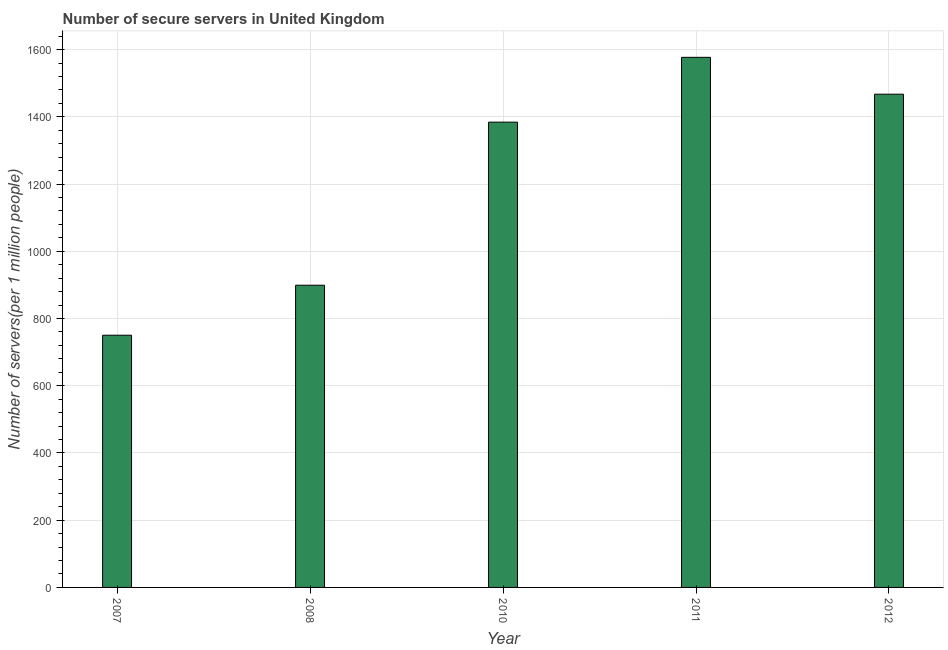Does the graph contain grids?
Provide a short and direct response. Yes. What is the title of the graph?
Offer a very short reply. Number of secure servers in United Kingdom. What is the label or title of the X-axis?
Provide a succinct answer. Year. What is the label or title of the Y-axis?
Your answer should be very brief. Number of servers(per 1 million people). What is the number of secure internet servers in 2012?
Your answer should be compact. 1467.31. Across all years, what is the maximum number of secure internet servers?
Your answer should be very brief. 1576.98. Across all years, what is the minimum number of secure internet servers?
Your answer should be compact. 750.31. In which year was the number of secure internet servers maximum?
Keep it short and to the point. 2011. In which year was the number of secure internet servers minimum?
Provide a succinct answer. 2007. What is the sum of the number of secure internet servers?
Offer a very short reply. 6077.74. What is the difference between the number of secure internet servers in 2007 and 2012?
Ensure brevity in your answer.  -717. What is the average number of secure internet servers per year?
Your answer should be compact. 1215.55. What is the median number of secure internet servers?
Keep it short and to the point. 1384.15. What is the ratio of the number of secure internet servers in 2008 to that in 2010?
Offer a terse response. 0.65. What is the difference between the highest and the second highest number of secure internet servers?
Provide a succinct answer. 109.67. Is the sum of the number of secure internet servers in 2007 and 2012 greater than the maximum number of secure internet servers across all years?
Ensure brevity in your answer.  Yes. What is the difference between the highest and the lowest number of secure internet servers?
Offer a very short reply. 826.67. What is the difference between two consecutive major ticks on the Y-axis?
Keep it short and to the point. 200. Are the values on the major ticks of Y-axis written in scientific E-notation?
Give a very brief answer. No. What is the Number of servers(per 1 million people) in 2007?
Your response must be concise. 750.31. What is the Number of servers(per 1 million people) in 2008?
Ensure brevity in your answer.  898.99. What is the Number of servers(per 1 million people) of 2010?
Your answer should be very brief. 1384.15. What is the Number of servers(per 1 million people) of 2011?
Keep it short and to the point. 1576.98. What is the Number of servers(per 1 million people) in 2012?
Ensure brevity in your answer.  1467.31. What is the difference between the Number of servers(per 1 million people) in 2007 and 2008?
Your answer should be compact. -148.68. What is the difference between the Number of servers(per 1 million people) in 2007 and 2010?
Provide a short and direct response. -633.84. What is the difference between the Number of servers(per 1 million people) in 2007 and 2011?
Offer a terse response. -826.67. What is the difference between the Number of servers(per 1 million people) in 2007 and 2012?
Provide a short and direct response. -717. What is the difference between the Number of servers(per 1 million people) in 2008 and 2010?
Ensure brevity in your answer.  -485.16. What is the difference between the Number of servers(per 1 million people) in 2008 and 2011?
Provide a short and direct response. -677.99. What is the difference between the Number of servers(per 1 million people) in 2008 and 2012?
Offer a very short reply. -568.32. What is the difference between the Number of servers(per 1 million people) in 2010 and 2011?
Your response must be concise. -192.83. What is the difference between the Number of servers(per 1 million people) in 2010 and 2012?
Make the answer very short. -83.16. What is the difference between the Number of servers(per 1 million people) in 2011 and 2012?
Ensure brevity in your answer.  109.67. What is the ratio of the Number of servers(per 1 million people) in 2007 to that in 2008?
Your answer should be compact. 0.83. What is the ratio of the Number of servers(per 1 million people) in 2007 to that in 2010?
Your answer should be very brief. 0.54. What is the ratio of the Number of servers(per 1 million people) in 2007 to that in 2011?
Provide a short and direct response. 0.48. What is the ratio of the Number of servers(per 1 million people) in 2007 to that in 2012?
Your response must be concise. 0.51. What is the ratio of the Number of servers(per 1 million people) in 2008 to that in 2010?
Your response must be concise. 0.65. What is the ratio of the Number of servers(per 1 million people) in 2008 to that in 2011?
Offer a very short reply. 0.57. What is the ratio of the Number of servers(per 1 million people) in 2008 to that in 2012?
Offer a terse response. 0.61. What is the ratio of the Number of servers(per 1 million people) in 2010 to that in 2011?
Give a very brief answer. 0.88. What is the ratio of the Number of servers(per 1 million people) in 2010 to that in 2012?
Offer a very short reply. 0.94. What is the ratio of the Number of servers(per 1 million people) in 2011 to that in 2012?
Provide a short and direct response. 1.07. 